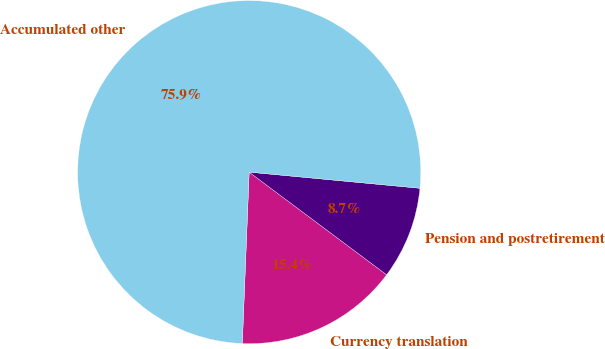Convert chart. <chart><loc_0><loc_0><loc_500><loc_500><pie_chart><fcel>Currency translation<fcel>Pension and postretirement<fcel>Accumulated other<nl><fcel>15.43%<fcel>8.71%<fcel>75.87%<nl></chart> 